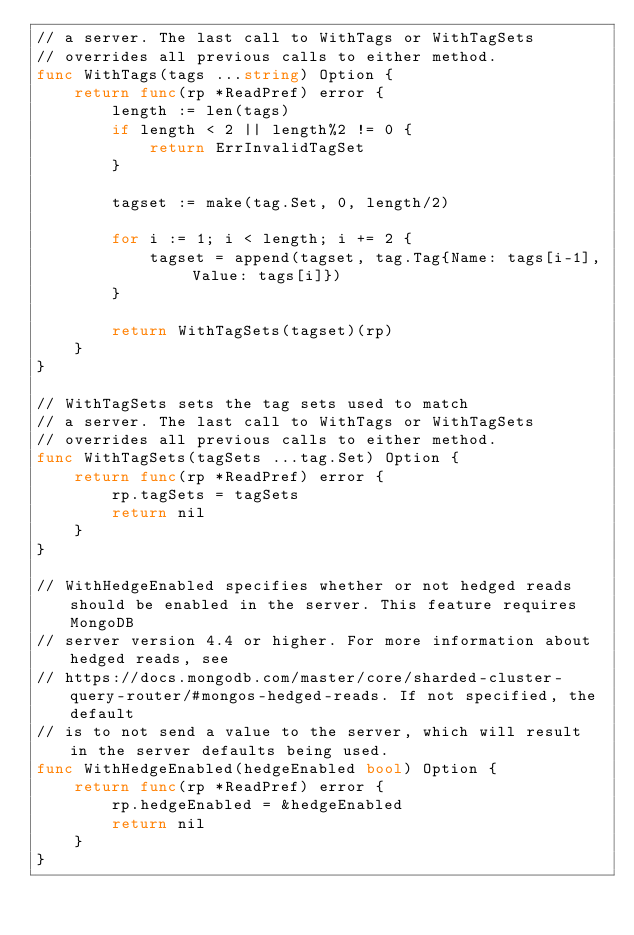<code> <loc_0><loc_0><loc_500><loc_500><_Go_>// a server. The last call to WithTags or WithTagSets
// overrides all previous calls to either method.
func WithTags(tags ...string) Option {
	return func(rp *ReadPref) error {
		length := len(tags)
		if length < 2 || length%2 != 0 {
			return ErrInvalidTagSet
		}

		tagset := make(tag.Set, 0, length/2)

		for i := 1; i < length; i += 2 {
			tagset = append(tagset, tag.Tag{Name: tags[i-1], Value: tags[i]})
		}

		return WithTagSets(tagset)(rp)
	}
}

// WithTagSets sets the tag sets used to match
// a server. The last call to WithTags or WithTagSets
// overrides all previous calls to either method.
func WithTagSets(tagSets ...tag.Set) Option {
	return func(rp *ReadPref) error {
		rp.tagSets = tagSets
		return nil
	}
}

// WithHedgeEnabled specifies whether or not hedged reads should be enabled in the server. This feature requires MongoDB
// server version 4.4 or higher. For more information about hedged reads, see
// https://docs.mongodb.com/master/core/sharded-cluster-query-router/#mongos-hedged-reads. If not specified, the default
// is to not send a value to the server, which will result in the server defaults being used.
func WithHedgeEnabled(hedgeEnabled bool) Option {
	return func(rp *ReadPref) error {
		rp.hedgeEnabled = &hedgeEnabled
		return nil
	}
}
</code> 